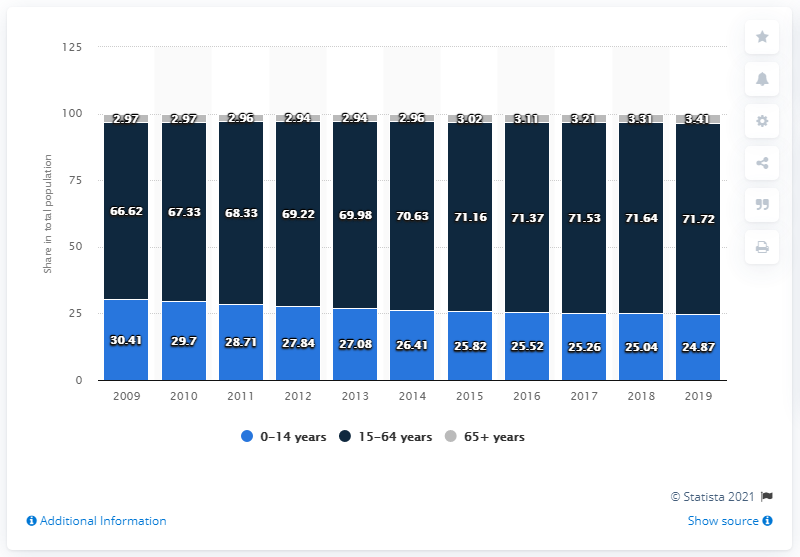Mention a couple of crucial points in this snapshot. In 2019, approximately 3.41% of Saudi Arabia's population was between the ages of 65 and 65. 